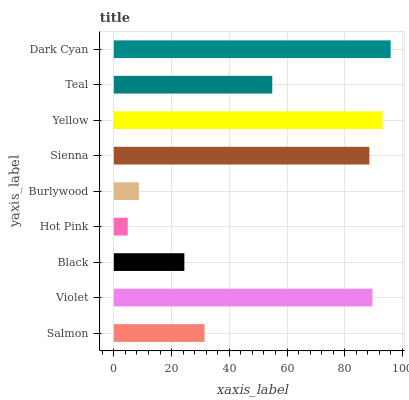Is Hot Pink the minimum?
Answer yes or no. Yes. Is Dark Cyan the maximum?
Answer yes or no. Yes. Is Violet the minimum?
Answer yes or no. No. Is Violet the maximum?
Answer yes or no. No. Is Violet greater than Salmon?
Answer yes or no. Yes. Is Salmon less than Violet?
Answer yes or no. Yes. Is Salmon greater than Violet?
Answer yes or no. No. Is Violet less than Salmon?
Answer yes or no. No. Is Teal the high median?
Answer yes or no. Yes. Is Teal the low median?
Answer yes or no. Yes. Is Sienna the high median?
Answer yes or no. No. Is Hot Pink the low median?
Answer yes or no. No. 